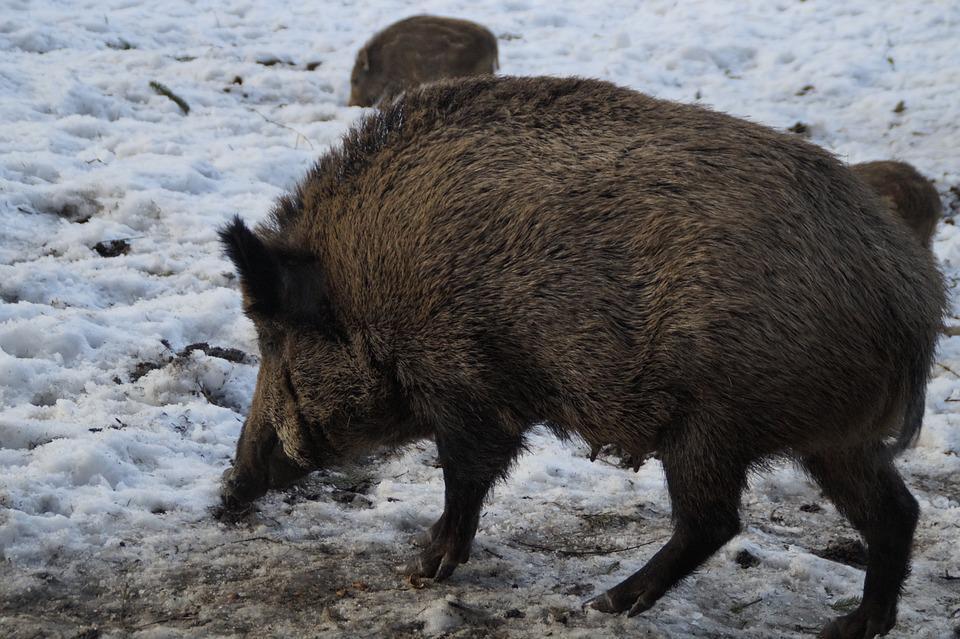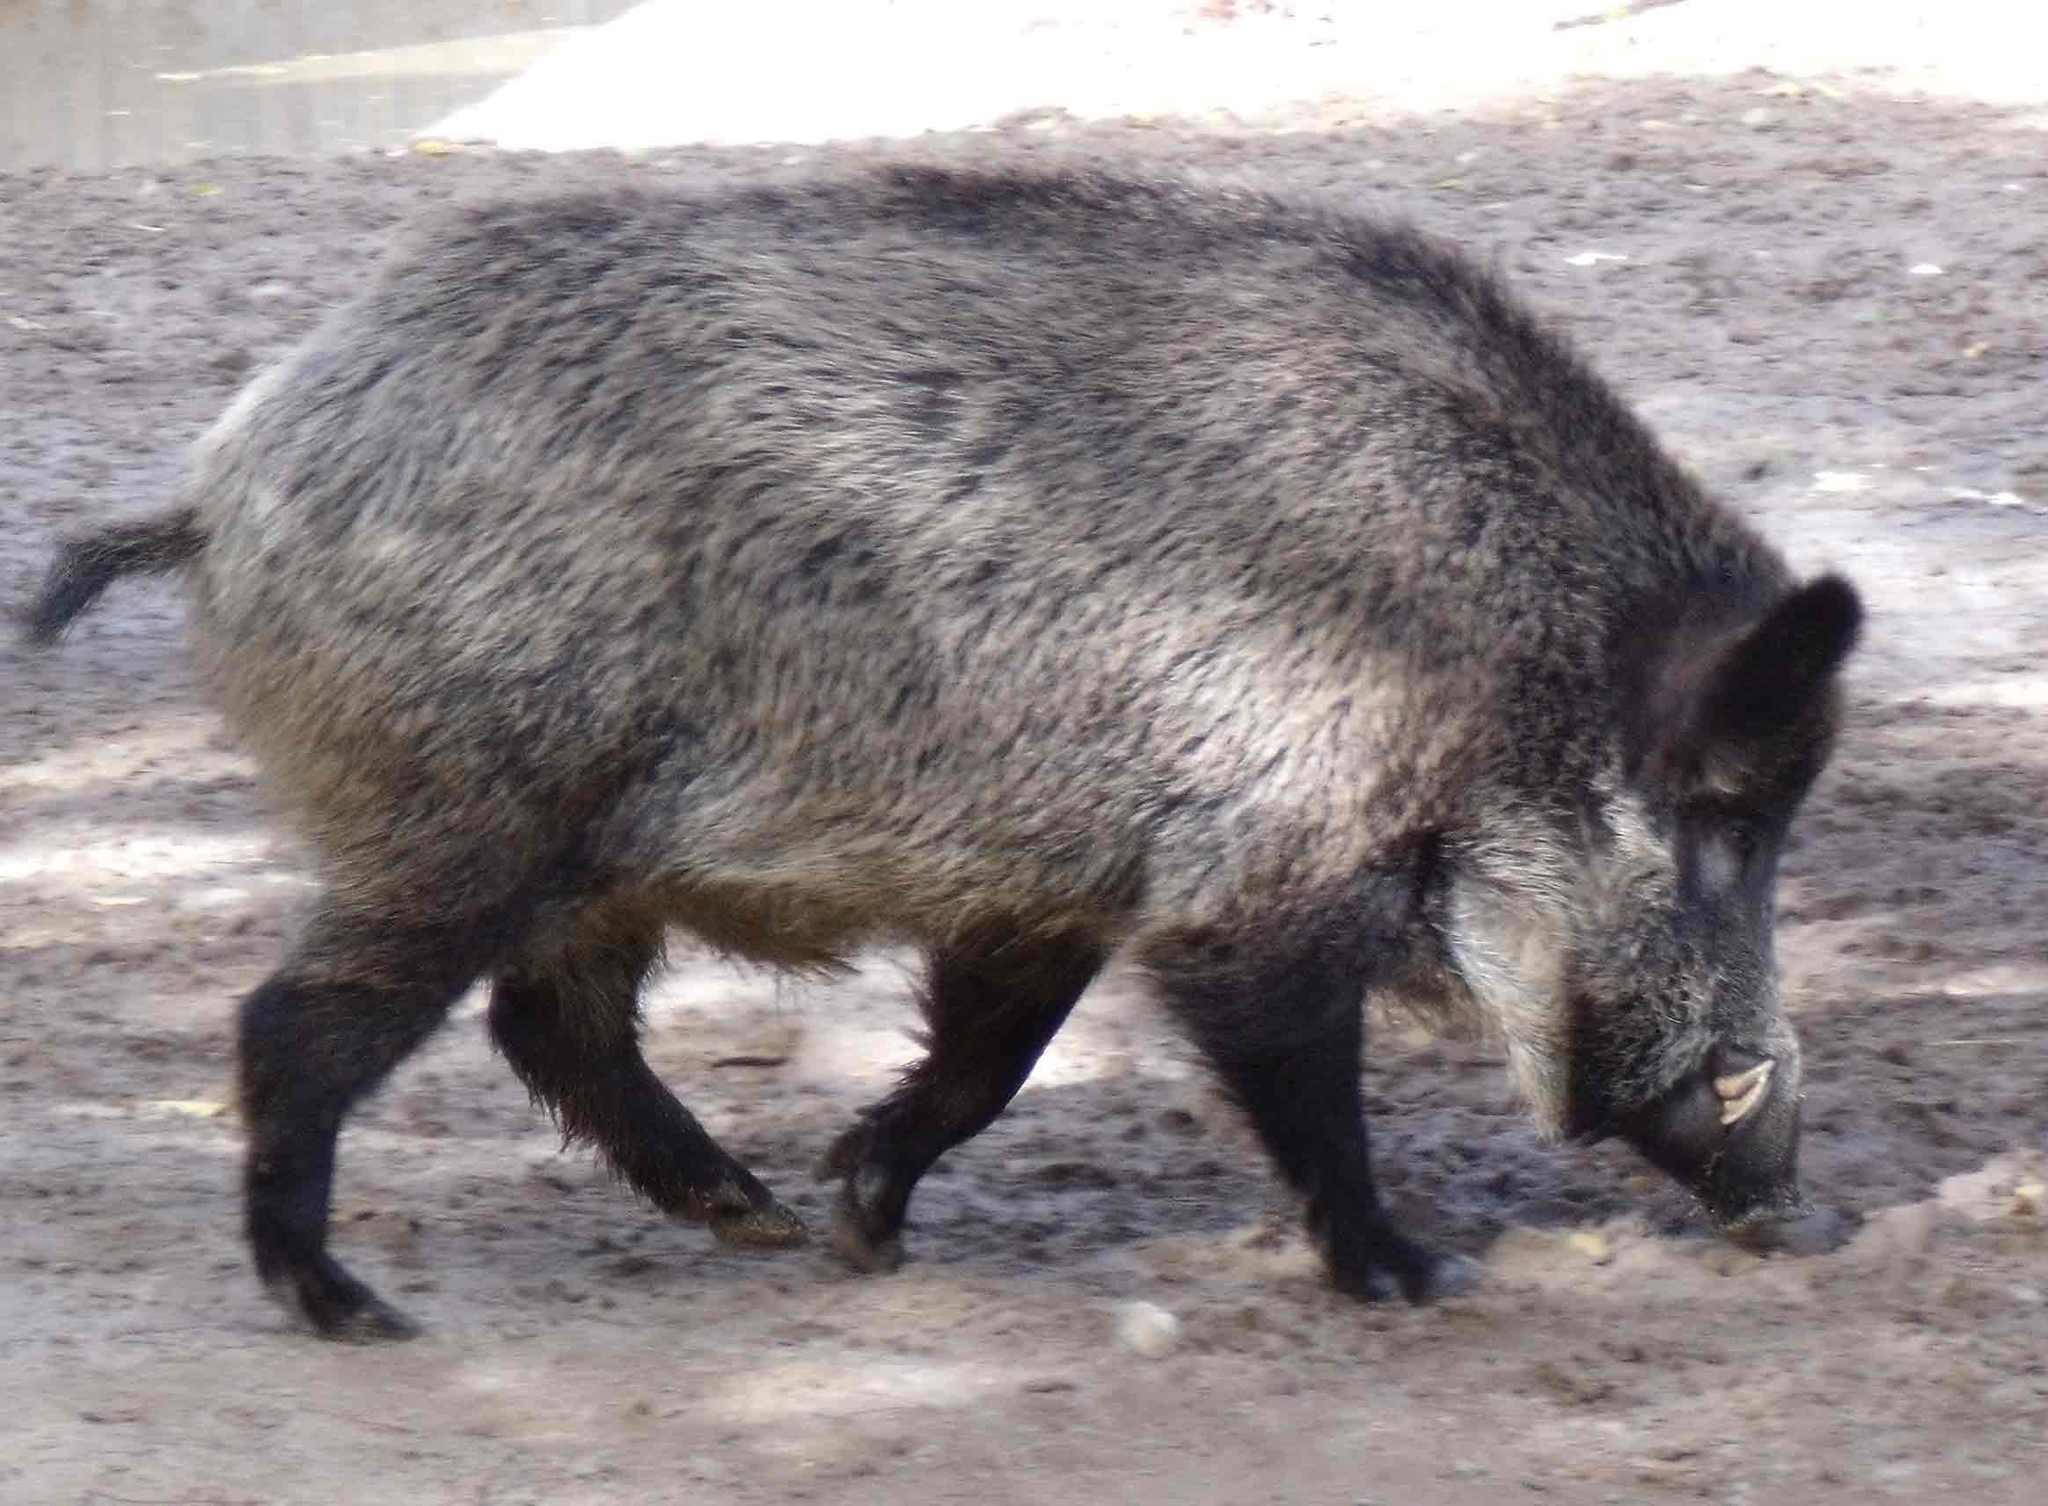The first image is the image on the left, the second image is the image on the right. Analyze the images presented: Is the assertion "The one boar in the left image is facing more toward the camera than the boar in the right image." valid? Answer yes or no. No. 